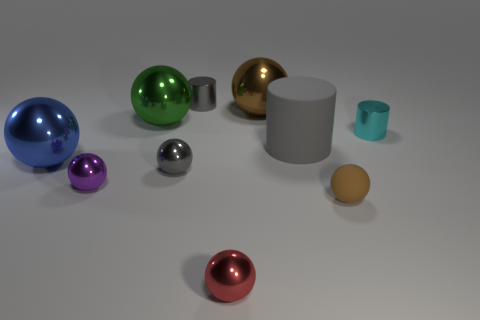Subtract all blue balls. How many balls are left? 6 Subtract all tiny metal spheres. How many spheres are left? 4 Subtract all gray spheres. Subtract all cyan blocks. How many spheres are left? 6 Subtract all spheres. How many objects are left? 3 Add 10 large green rubber things. How many large green rubber things exist? 10 Subtract 0 brown blocks. How many objects are left? 10 Subtract all gray matte cylinders. Subtract all green spheres. How many objects are left? 8 Add 4 metallic balls. How many metallic balls are left? 10 